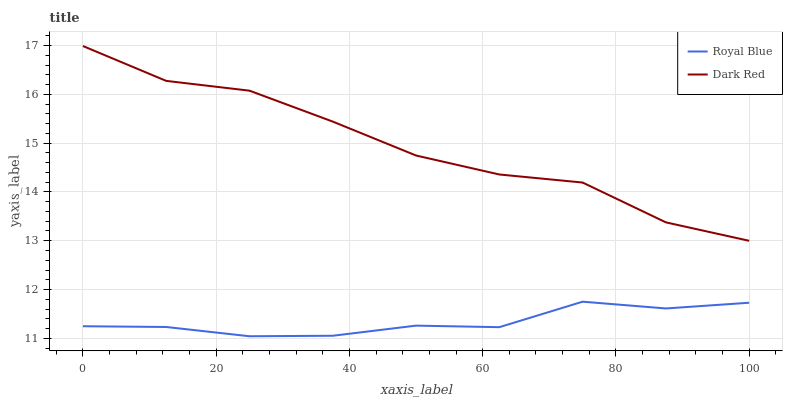Does Royal Blue have the minimum area under the curve?
Answer yes or no. Yes. Does Dark Red have the maximum area under the curve?
Answer yes or no. Yes. Does Dark Red have the minimum area under the curve?
Answer yes or no. No. Is Royal Blue the smoothest?
Answer yes or no. Yes. Is Dark Red the roughest?
Answer yes or no. Yes. Is Dark Red the smoothest?
Answer yes or no. No. Does Dark Red have the lowest value?
Answer yes or no. No. Does Dark Red have the highest value?
Answer yes or no. Yes. Is Royal Blue less than Dark Red?
Answer yes or no. Yes. Is Dark Red greater than Royal Blue?
Answer yes or no. Yes. Does Royal Blue intersect Dark Red?
Answer yes or no. No. 